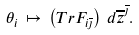<formula> <loc_0><loc_0><loc_500><loc_500>\theta _ { i } \, \mapsto \, \left ( T r F _ { i \overline { \jmath } } \right ) \, d \overline { z } ^ { \overline { \jmath } } .</formula> 